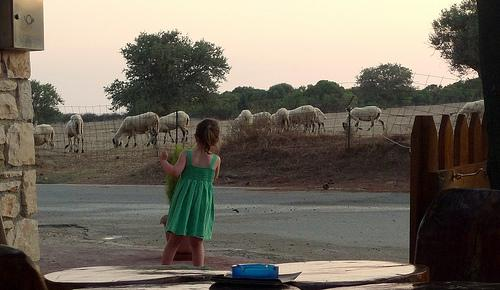Question: who is with her?
Choices:
A. Boyfriend.
B. Father.
C. Nobody.
D. Mother.
Answer with the letter. Answer: C Question: what are the horses doing?
Choices:
A. Grazing.
B. Defacating.
C. Eating.
D. Galloping.
Answer with the letter. Answer: C 